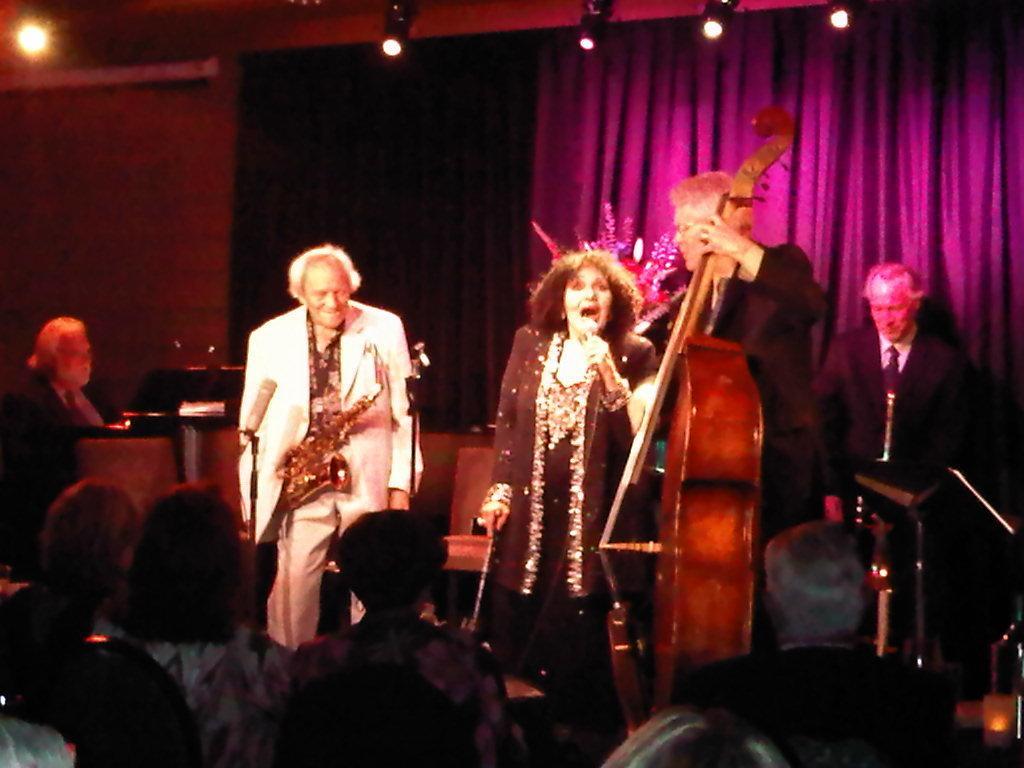Could you give a brief overview of what you see in this image? In this picture I can see there are a few people standing on the dais, the woman is holding a microphone and singing, there is a man standing and he is playing the violin and there is a person sitting at left and there are few lights attached to the ceiling and there are few lights attached to the ceiling. 